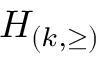Convert formula to latex. <formula><loc_0><loc_0><loc_500><loc_500>H _ { ( k , \geq ) }</formula> 